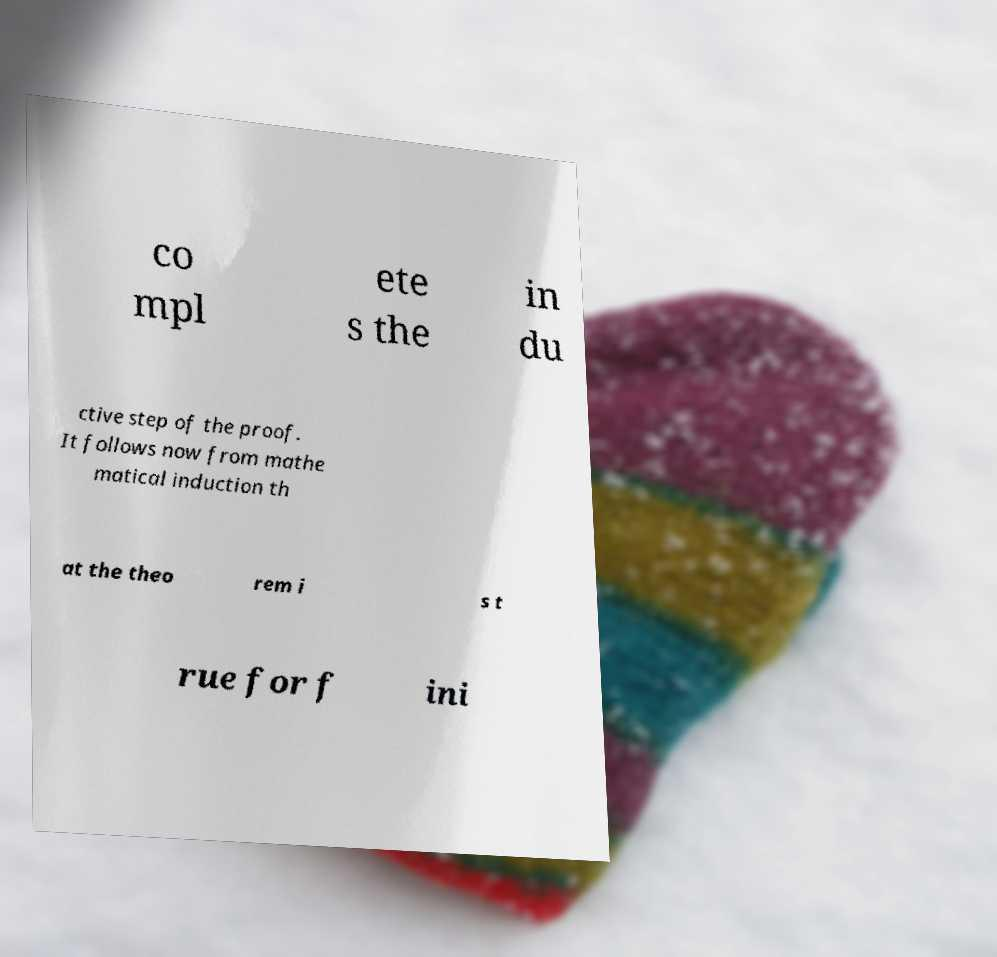Please identify and transcribe the text found in this image. co mpl ete s the in du ctive step of the proof. It follows now from mathe matical induction th at the theo rem i s t rue for f ini 